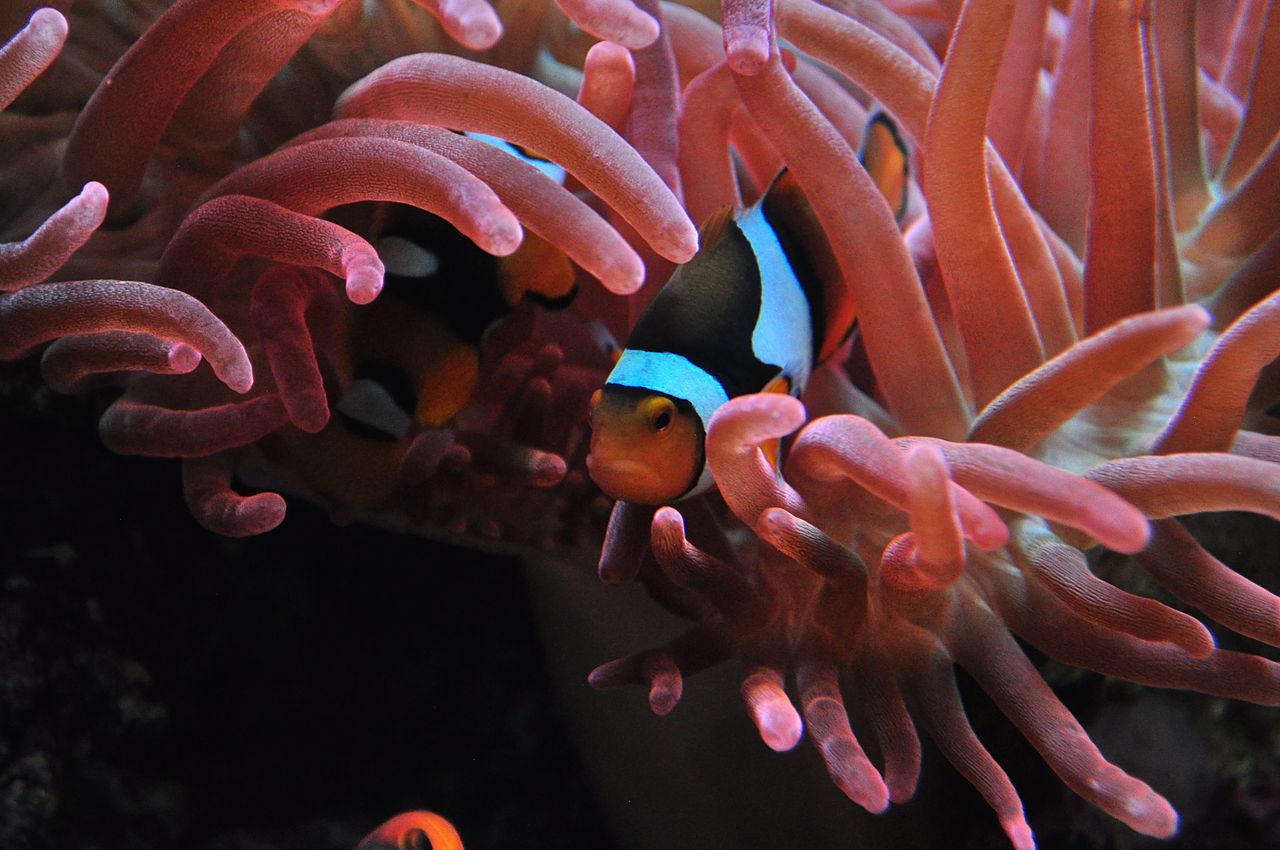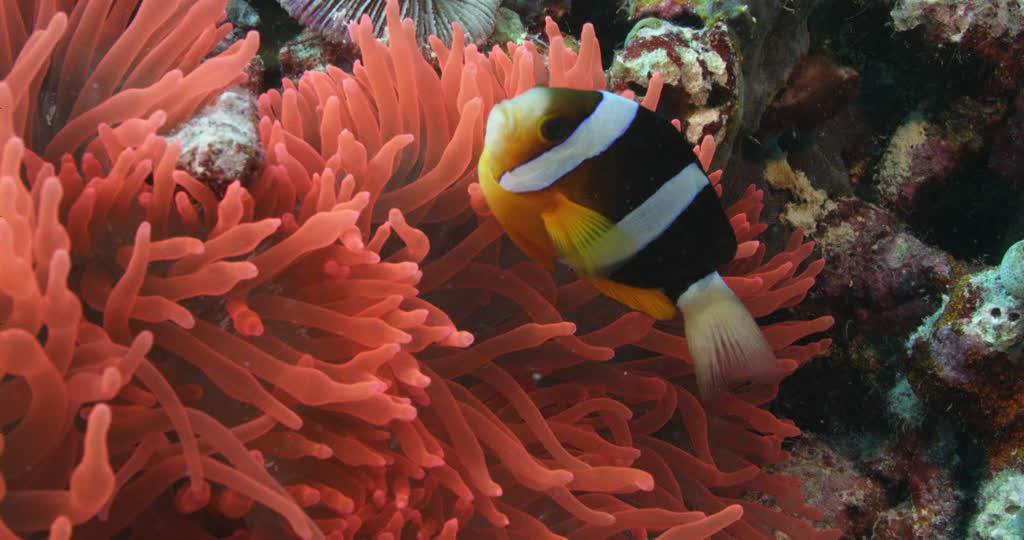The first image is the image on the left, the second image is the image on the right. Considering the images on both sides, is "there is a clown fish in the image on the right" valid? Answer yes or no. Yes. The first image is the image on the left, the second image is the image on the right. For the images shown, is this caption "There is a clownfish in at least one image." true? Answer yes or no. Yes. 